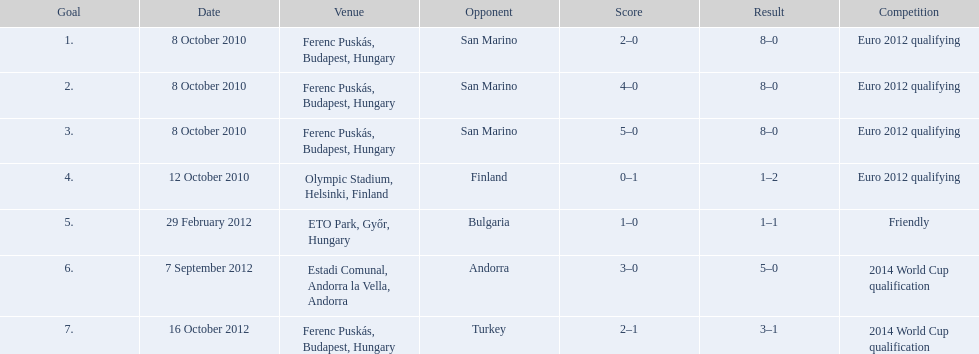How many goals were scored at the euro 2012 qualifying competition? 12. 